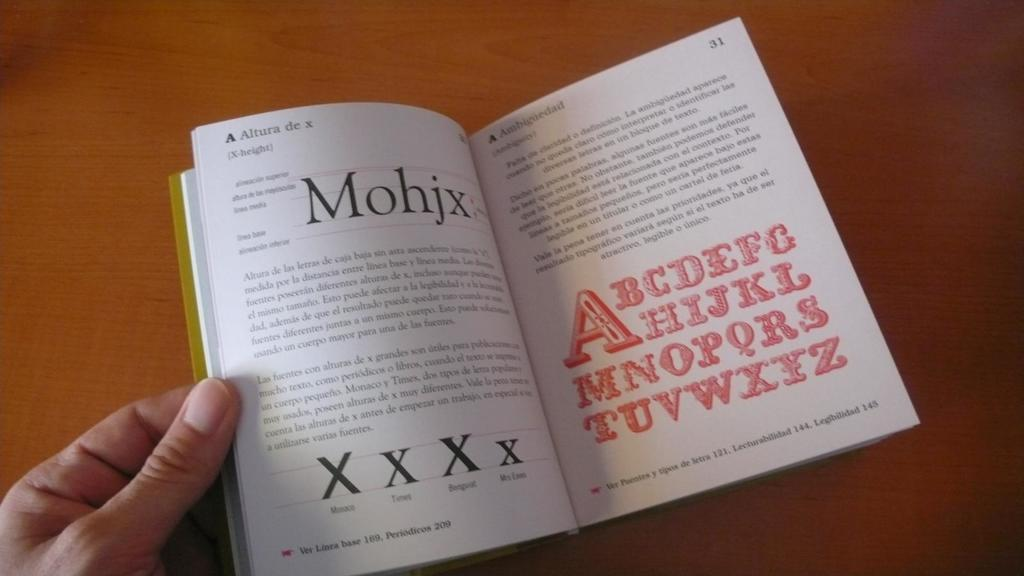<image>
Relay a brief, clear account of the picture shown. A hand holds open a book with the word Mohjx on a table. 